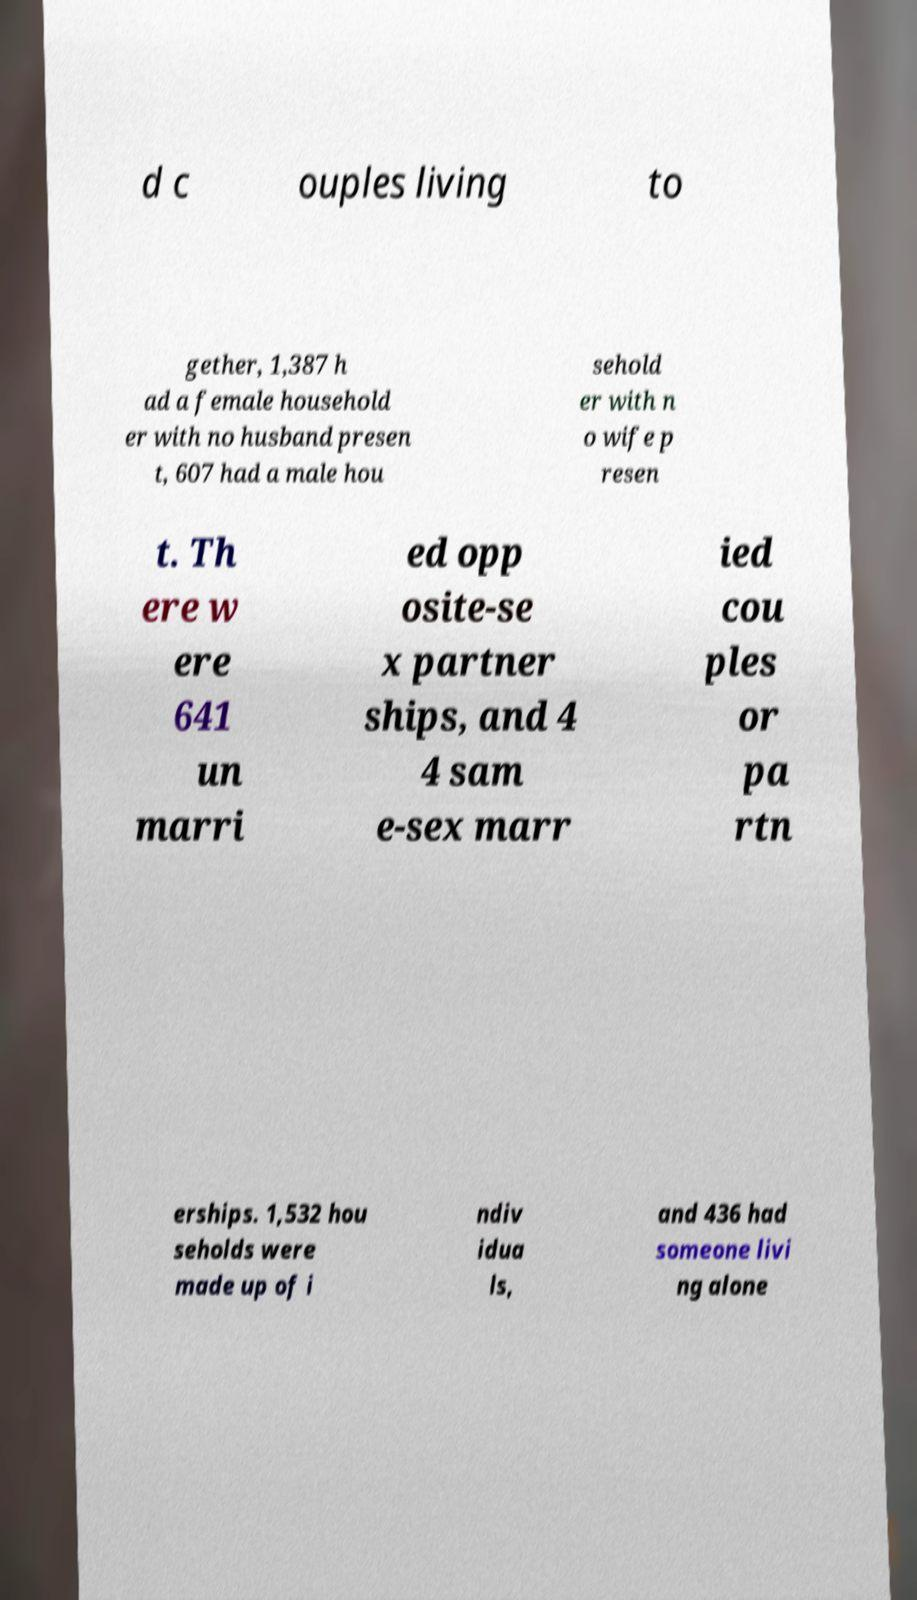Could you assist in decoding the text presented in this image and type it out clearly? d c ouples living to gether, 1,387 h ad a female household er with no husband presen t, 607 had a male hou sehold er with n o wife p resen t. Th ere w ere 641 un marri ed opp osite-se x partner ships, and 4 4 sam e-sex marr ied cou ples or pa rtn erships. 1,532 hou seholds were made up of i ndiv idua ls, and 436 had someone livi ng alone 